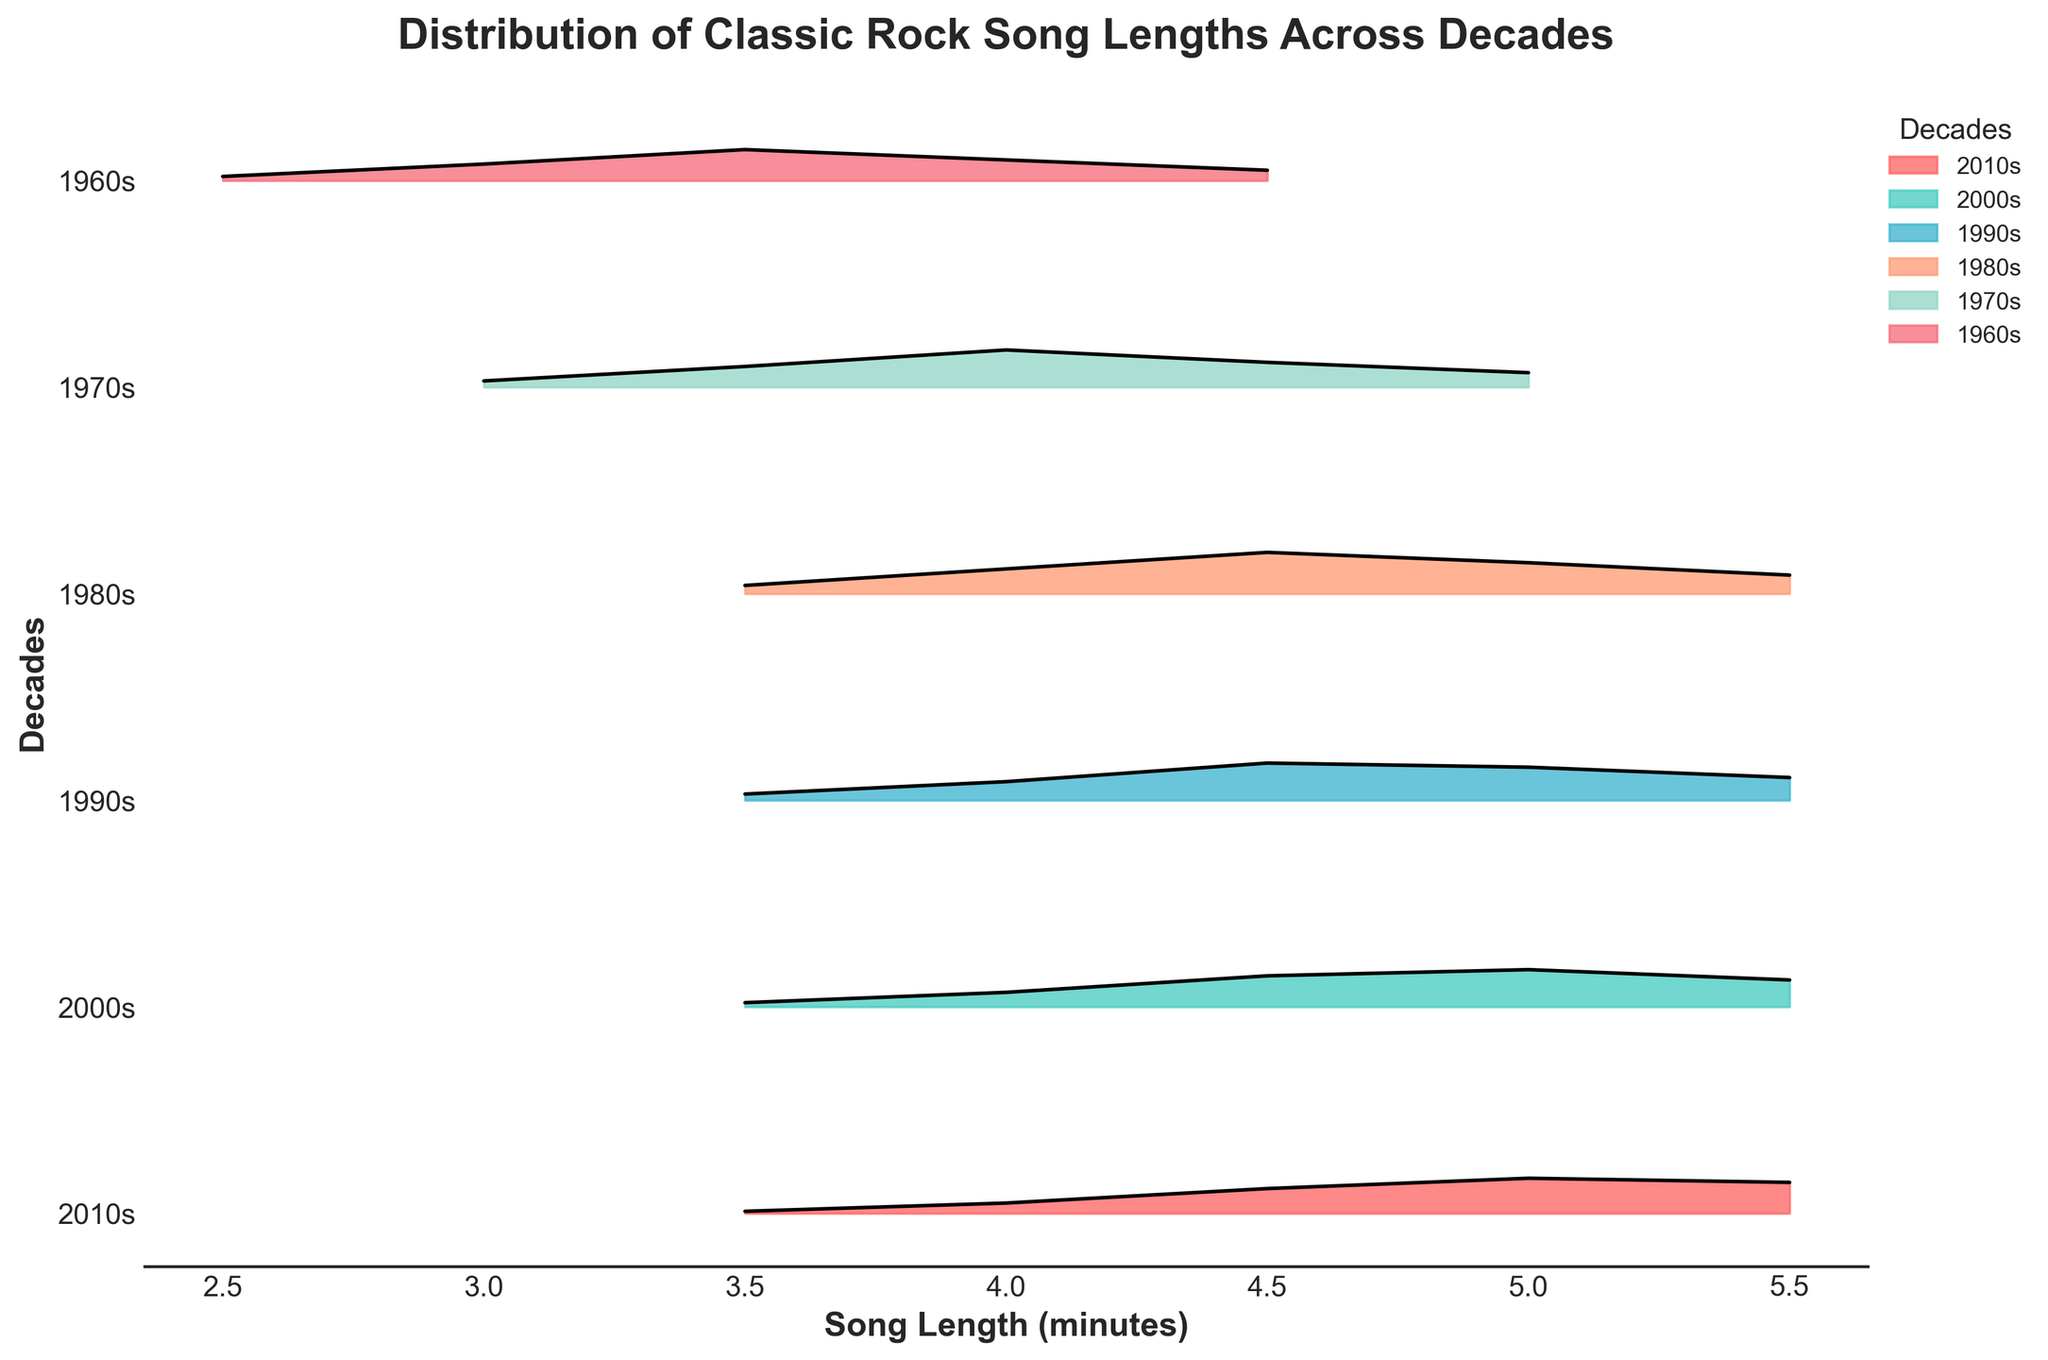What is the title of the plot? The title is usually at the top of the plot, written in bigger and bold text.
Answer: Distribution of Classic Rock Song Lengths Across Decades Which decade has the highest density at a song length of 4.0 minutes? By examining the height of the densities at 4.0 minutes across all the decades, the 1970s has the highest density.
Answer: 1970s What song length interval has the highest density in the 1980s? By referring to the plot, the peak density for the 1980s occurs at 4.5 minutes.
Answer: 4.5 minutes Do the song lengths tend to increase or decrease over the decades? By comparing the position and length of the densities, it's noticeable that the peak densities shift towards longer song lengths in more recent decades.
Answer: Increase Rank the decades based on average song length, from shortest to longest. To determine this, observe the position of the peaks in each decade's distribution: 1960s < 1970s < 1980s < 1990s < 2000s < 2010s.
Answer: 1960s, 1970s, 1980s, 1990s, 2000s, 2010s Which decade has the densest distribution overall? This can be judged by observing which decade has the most prolonged and prominent density spread. The 2000s and 2010s stand out with high density extending over a wide range of song lengths.
Answer: 2000s or 2010s Are there any song lengths that all decades share a density for? By examining the plot, all decades have densities for 3.5 minutes and 4.0 minutes.
Answer: 3.5 minutes and 4.0 minutes Which decade has the lowest density at 5.5 minutes? Check the density heights at 5.5 minutes for all decades; the 1960s have no density at this length compared to others.
Answer: 1960s 